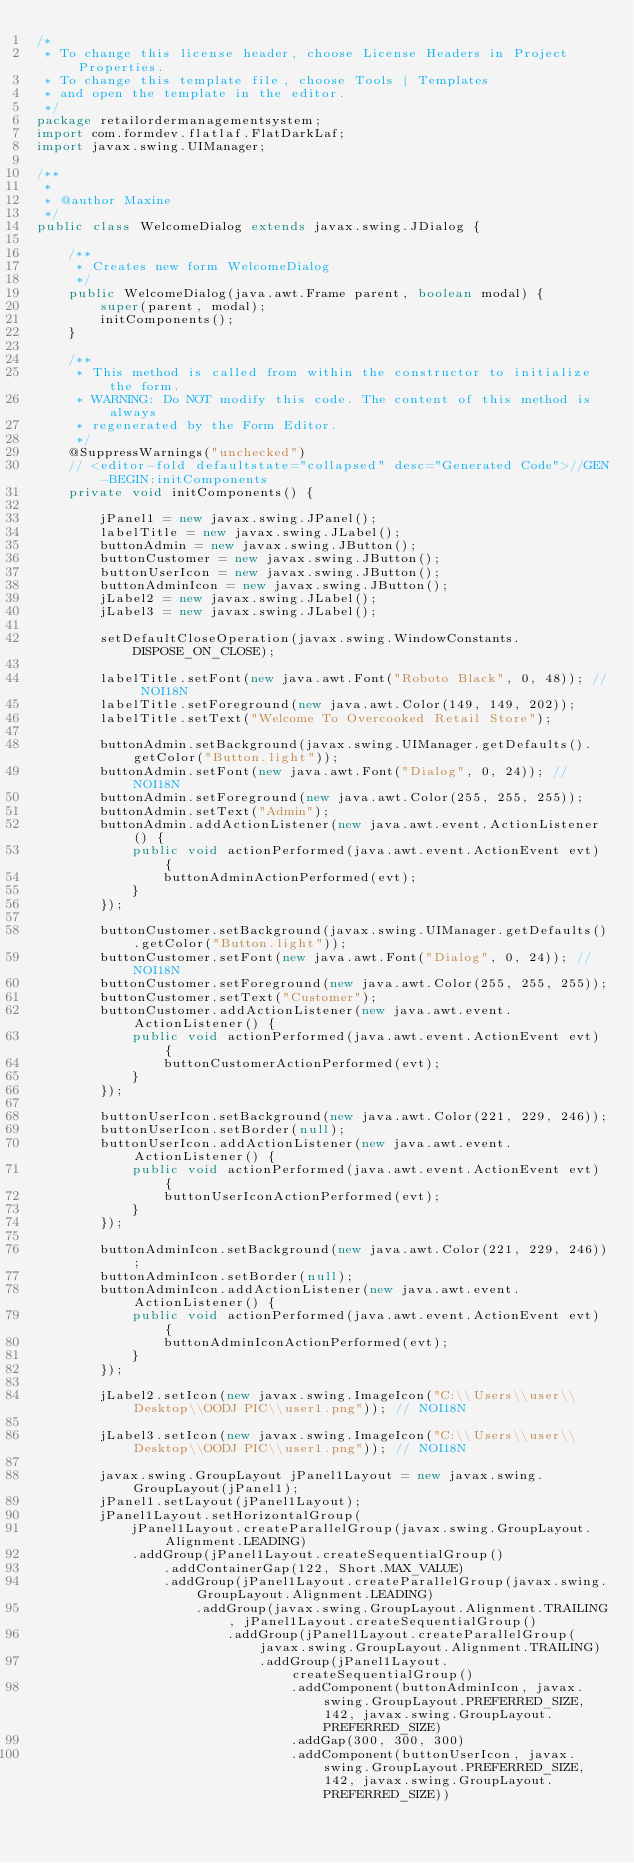<code> <loc_0><loc_0><loc_500><loc_500><_Java_>/*
 * To change this license header, choose License Headers in Project Properties.
 * To change this template file, choose Tools | Templates
 * and open the template in the editor.
 */
package retailordermanagementsystem;
import com.formdev.flatlaf.FlatDarkLaf;
import javax.swing.UIManager;

/**
 *
 * @author Maxine
 */
public class WelcomeDialog extends javax.swing.JDialog {

    /**
     * Creates new form WelcomeDialog
     */
    public WelcomeDialog(java.awt.Frame parent, boolean modal) {
        super(parent, modal);
        initComponents();
    }

    /**
     * This method is called from within the constructor to initialize the form.
     * WARNING: Do NOT modify this code. The content of this method is always
     * regenerated by the Form Editor.
     */
    @SuppressWarnings("unchecked")
    // <editor-fold defaultstate="collapsed" desc="Generated Code">//GEN-BEGIN:initComponents
    private void initComponents() {

        jPanel1 = new javax.swing.JPanel();
        labelTitle = new javax.swing.JLabel();
        buttonAdmin = new javax.swing.JButton();
        buttonCustomer = new javax.swing.JButton();
        buttonUserIcon = new javax.swing.JButton();
        buttonAdminIcon = new javax.swing.JButton();
        jLabel2 = new javax.swing.JLabel();
        jLabel3 = new javax.swing.JLabel();

        setDefaultCloseOperation(javax.swing.WindowConstants.DISPOSE_ON_CLOSE);

        labelTitle.setFont(new java.awt.Font("Roboto Black", 0, 48)); // NOI18N
        labelTitle.setForeground(new java.awt.Color(149, 149, 202));
        labelTitle.setText("Welcome To Overcooked Retail Store");

        buttonAdmin.setBackground(javax.swing.UIManager.getDefaults().getColor("Button.light"));
        buttonAdmin.setFont(new java.awt.Font("Dialog", 0, 24)); // NOI18N
        buttonAdmin.setForeground(new java.awt.Color(255, 255, 255));
        buttonAdmin.setText("Admin");
        buttonAdmin.addActionListener(new java.awt.event.ActionListener() {
            public void actionPerformed(java.awt.event.ActionEvent evt) {
                buttonAdminActionPerformed(evt);
            }
        });

        buttonCustomer.setBackground(javax.swing.UIManager.getDefaults().getColor("Button.light"));
        buttonCustomer.setFont(new java.awt.Font("Dialog", 0, 24)); // NOI18N
        buttonCustomer.setForeground(new java.awt.Color(255, 255, 255));
        buttonCustomer.setText("Customer");
        buttonCustomer.addActionListener(new java.awt.event.ActionListener() {
            public void actionPerformed(java.awt.event.ActionEvent evt) {
                buttonCustomerActionPerformed(evt);
            }
        });

        buttonUserIcon.setBackground(new java.awt.Color(221, 229, 246));
        buttonUserIcon.setBorder(null);
        buttonUserIcon.addActionListener(new java.awt.event.ActionListener() {
            public void actionPerformed(java.awt.event.ActionEvent evt) {
                buttonUserIconActionPerformed(evt);
            }
        });

        buttonAdminIcon.setBackground(new java.awt.Color(221, 229, 246));
        buttonAdminIcon.setBorder(null);
        buttonAdminIcon.addActionListener(new java.awt.event.ActionListener() {
            public void actionPerformed(java.awt.event.ActionEvent evt) {
                buttonAdminIconActionPerformed(evt);
            }
        });

        jLabel2.setIcon(new javax.swing.ImageIcon("C:\\Users\\user\\Desktop\\OODJ PIC\\user1.png")); // NOI18N

        jLabel3.setIcon(new javax.swing.ImageIcon("C:\\Users\\user\\Desktop\\OODJ PIC\\user1.png")); // NOI18N

        javax.swing.GroupLayout jPanel1Layout = new javax.swing.GroupLayout(jPanel1);
        jPanel1.setLayout(jPanel1Layout);
        jPanel1Layout.setHorizontalGroup(
            jPanel1Layout.createParallelGroup(javax.swing.GroupLayout.Alignment.LEADING)
            .addGroup(jPanel1Layout.createSequentialGroup()
                .addContainerGap(122, Short.MAX_VALUE)
                .addGroup(jPanel1Layout.createParallelGroup(javax.swing.GroupLayout.Alignment.LEADING)
                    .addGroup(javax.swing.GroupLayout.Alignment.TRAILING, jPanel1Layout.createSequentialGroup()
                        .addGroup(jPanel1Layout.createParallelGroup(javax.swing.GroupLayout.Alignment.TRAILING)
                            .addGroup(jPanel1Layout.createSequentialGroup()
                                .addComponent(buttonAdminIcon, javax.swing.GroupLayout.PREFERRED_SIZE, 142, javax.swing.GroupLayout.PREFERRED_SIZE)
                                .addGap(300, 300, 300)
                                .addComponent(buttonUserIcon, javax.swing.GroupLayout.PREFERRED_SIZE, 142, javax.swing.GroupLayout.PREFERRED_SIZE))</code> 